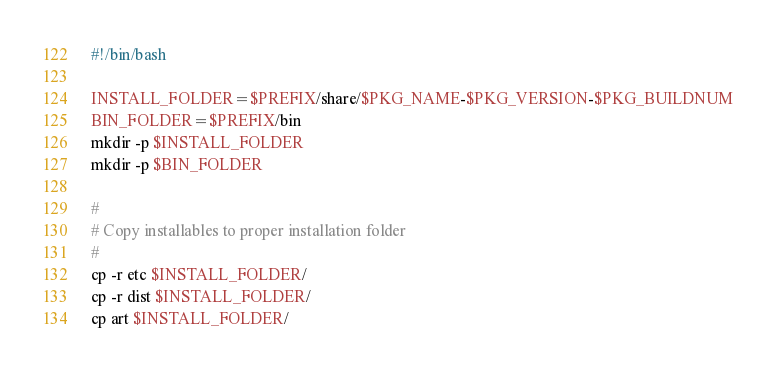<code> <loc_0><loc_0><loc_500><loc_500><_Bash_>#!/bin/bash

INSTALL_FOLDER=$PREFIX/share/$PKG_NAME-$PKG_VERSION-$PKG_BUILDNUM
BIN_FOLDER=$PREFIX/bin
mkdir -p $INSTALL_FOLDER
mkdir -p $BIN_FOLDER

#
# Copy installables to proper installation folder
#
cp -r etc $INSTALL_FOLDER/
cp -r dist $INSTALL_FOLDER/
cp art $INSTALL_FOLDER/</code> 